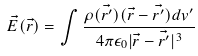Convert formula to latex. <formula><loc_0><loc_0><loc_500><loc_500>\vec { E } ( \vec { r } ) = \int \frac { \rho ( \vec { r ^ { \prime } } ) ( \vec { r } - \vec { r ^ { \prime } } ) d { v ^ { \prime } } } { 4 \pi \epsilon _ { 0 } | \vec { r } - \vec { r ^ { \prime } } | ^ { 3 } }</formula> 